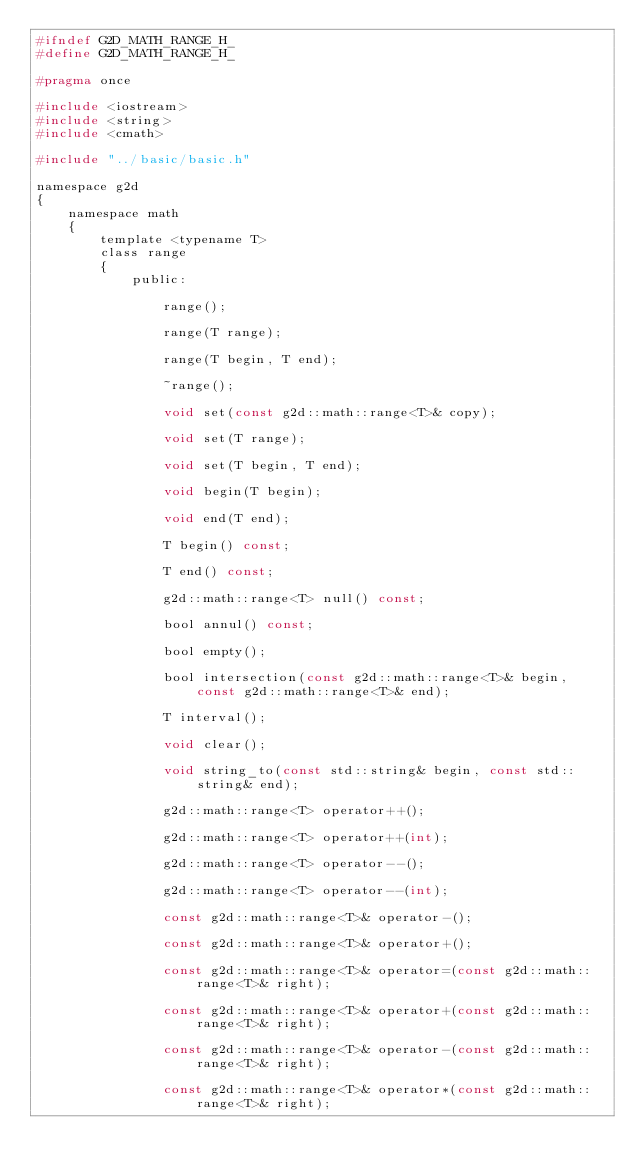<code> <loc_0><loc_0><loc_500><loc_500><_C_>#ifndef G2D_MATH_RANGE_H_
#define G2D_MATH_RANGE_H_

#pragma once

#include <iostream>
#include <string>
#include <cmath>

#include "../basic/basic.h"

namespace g2d
{
	namespace math
	{
		template <typename T>
		class range
		{
			public:

				range();

				range(T range);

				range(T begin, T end);

				~range();

				void set(const g2d::math::range<T>& copy);

				void set(T range);

				void set(T begin, T end);

				void begin(T begin);

				void end(T end);

				T begin() const;

				T end() const;

				g2d::math::range<T> null() const;

				bool annul() const;

				bool empty();

				bool intersection(const g2d::math::range<T>& begin, const g2d::math::range<T>& end);

				T interval();

				void clear();

				void string_to(const std::string& begin, const std::string& end);

				g2d::math::range<T> operator++();

				g2d::math::range<T> operator++(int);

				g2d::math::range<T> operator--();

				g2d::math::range<T> operator--(int);

				const g2d::math::range<T>& operator-();

				const g2d::math::range<T>& operator+();

				const g2d::math::range<T>& operator=(const g2d::math::range<T>& right);

				const g2d::math::range<T>& operator+(const g2d::math::range<T>& right);

				const g2d::math::range<T>& operator-(const g2d::math::range<T>& right);

				const g2d::math::range<T>& operator*(const g2d::math::range<T>& right);
</code> 